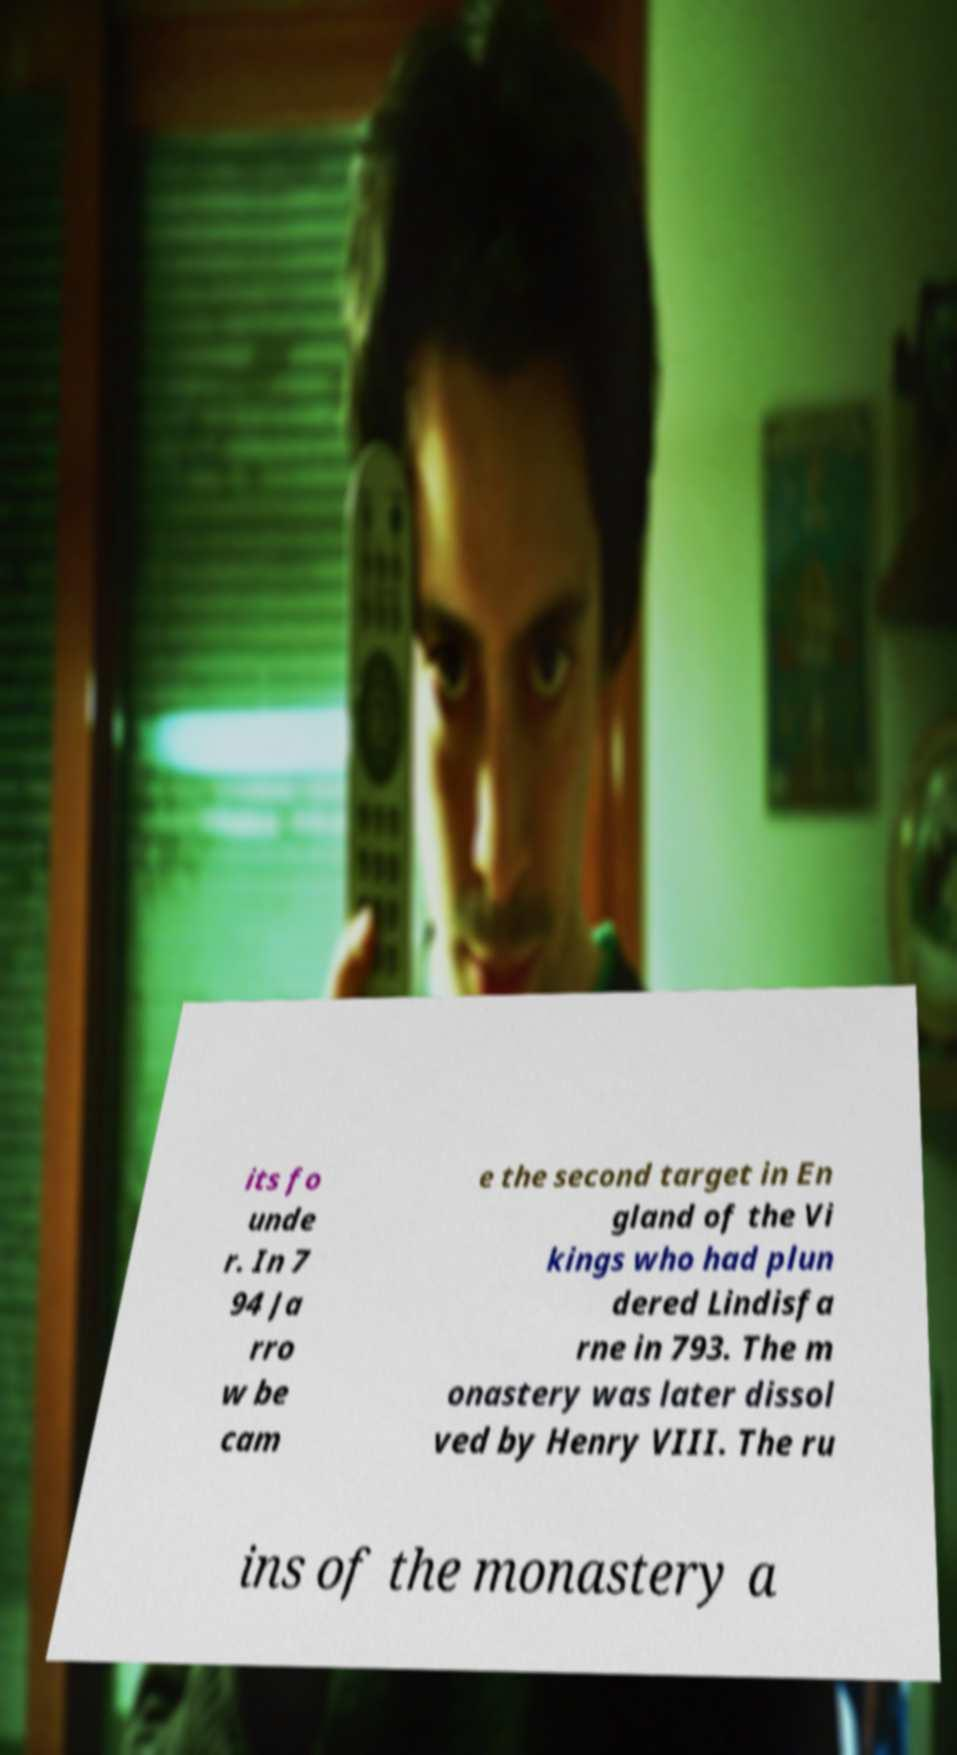Could you extract and type out the text from this image? its fo unde r. In 7 94 Ja rro w be cam e the second target in En gland of the Vi kings who had plun dered Lindisfa rne in 793. The m onastery was later dissol ved by Henry VIII. The ru ins of the monastery a 